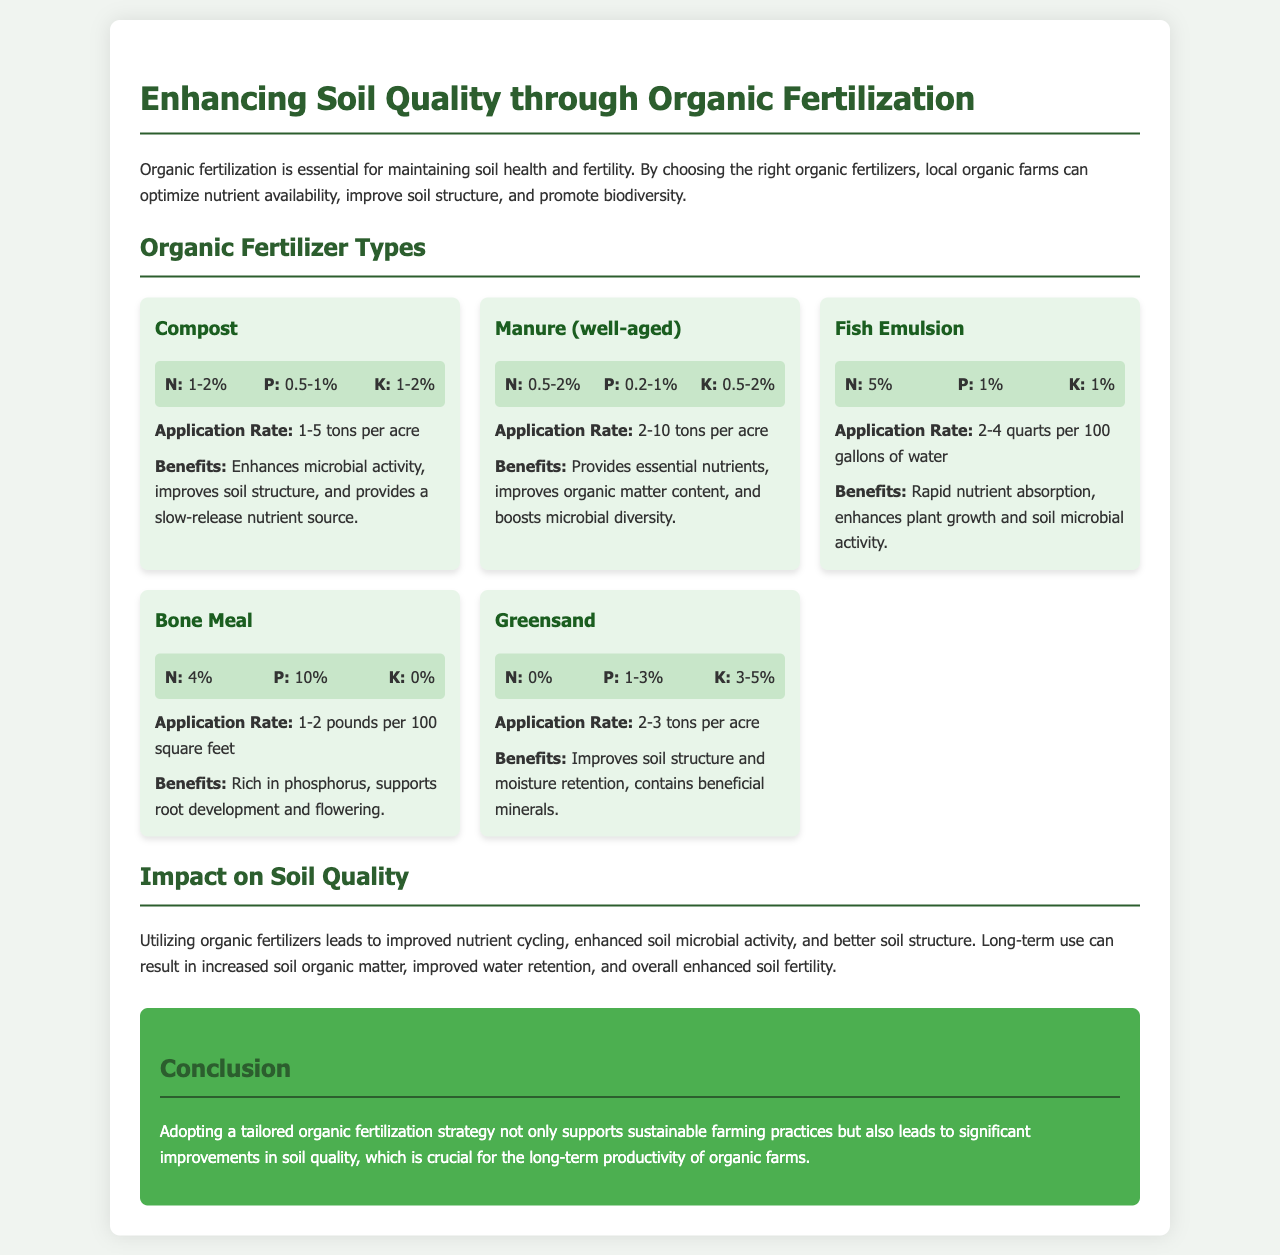What is the nitrogen content in compost? The nitrogen content in compost is between 1-2%.
Answer: 1-2% What is the application rate for fish emulsion? The application rate for fish emulsion is 2-4 quarts per 100 gallons of water.
Answer: 2-4 quarts per 100 gallons of water What is the benefit of using Greensand? Greensand improves soil structure and moisture retention, and contains beneficial minerals.
Answer: Improves soil structure and moisture retention What is the phosphorus content in bone meal? The phosphorus content in bone meal is 10%.
Answer: 10% How much can well-aged manure be applied per acre? Well-aged manure can be applied at a rate of 2-10 tons per acre.
Answer: 2-10 tons per acre What is a long-term effect of organic fertilization on soil? A long-term effect of organic fertilization is increased soil organic matter.
Answer: Increased soil organic matter What type of organic fertilizer has the highest nitrogen content? Fish emulsion has the highest nitrogen content at 5%.
Answer: Fish emulsion What overall impact does organic fertilization have on soil quality? Organic fertilization leads to improved nutrient cycling and enhanced soil microbial activity.
Answer: Improved nutrient cycling and enhanced soil microbial activity 